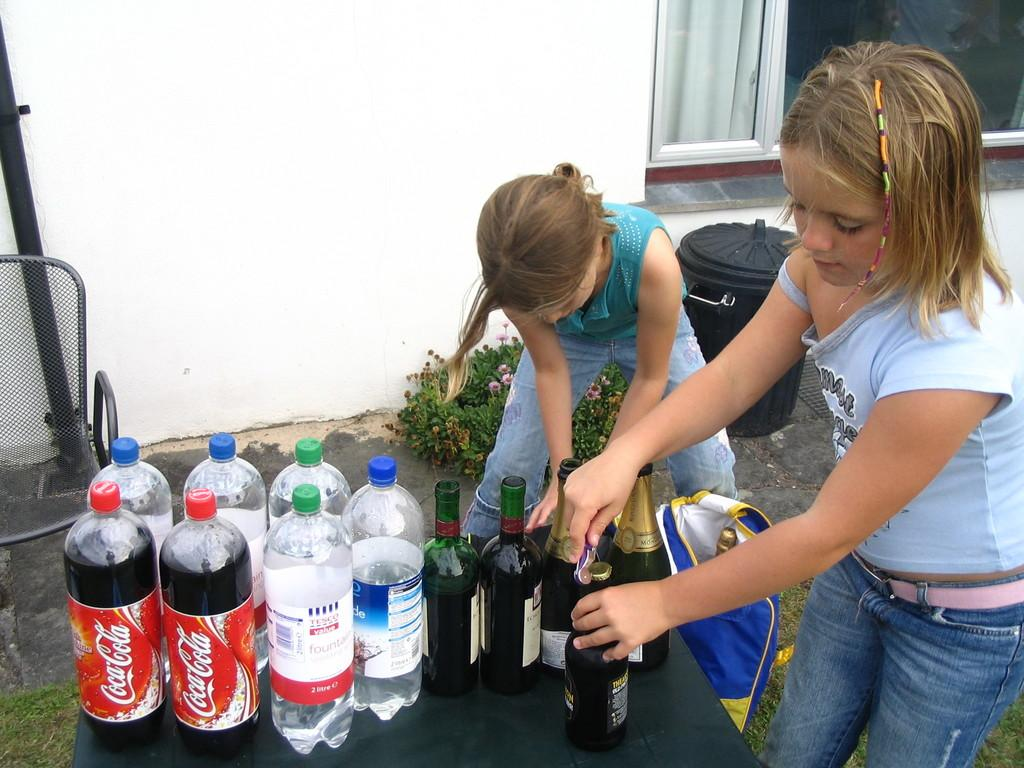How many people are in the image? There are two girls standing in the image. What objects can be seen in the image besides the girls? There are multiple bottles visible in the image. What can be seen in the background of the image? There is a plant and a container in the background of the image. What type of button is being used to water the plant in the image? There is no button present in the image, and the plant does not appear to be watered. 